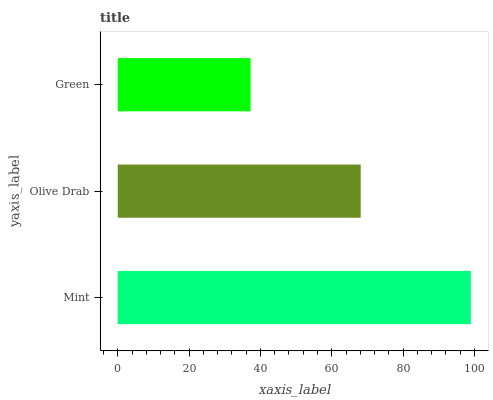Is Green the minimum?
Answer yes or no. Yes. Is Mint the maximum?
Answer yes or no. Yes. Is Olive Drab the minimum?
Answer yes or no. No. Is Olive Drab the maximum?
Answer yes or no. No. Is Mint greater than Olive Drab?
Answer yes or no. Yes. Is Olive Drab less than Mint?
Answer yes or no. Yes. Is Olive Drab greater than Mint?
Answer yes or no. No. Is Mint less than Olive Drab?
Answer yes or no. No. Is Olive Drab the high median?
Answer yes or no. Yes. Is Olive Drab the low median?
Answer yes or no. Yes. Is Mint the high median?
Answer yes or no. No. Is Mint the low median?
Answer yes or no. No. 